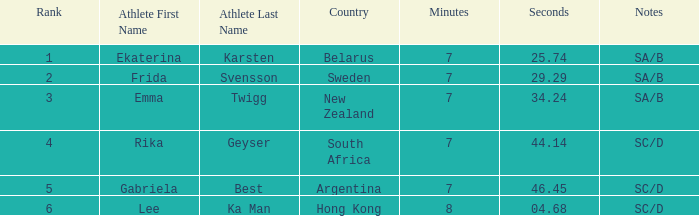What country is the athlete ekaterina karsten from with a rank less than 4? Belarus. 